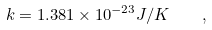<formula> <loc_0><loc_0><loc_500><loc_500>k = 1 . 3 8 1 \times 1 0 ^ { - 2 3 } J / K \quad ,</formula> 